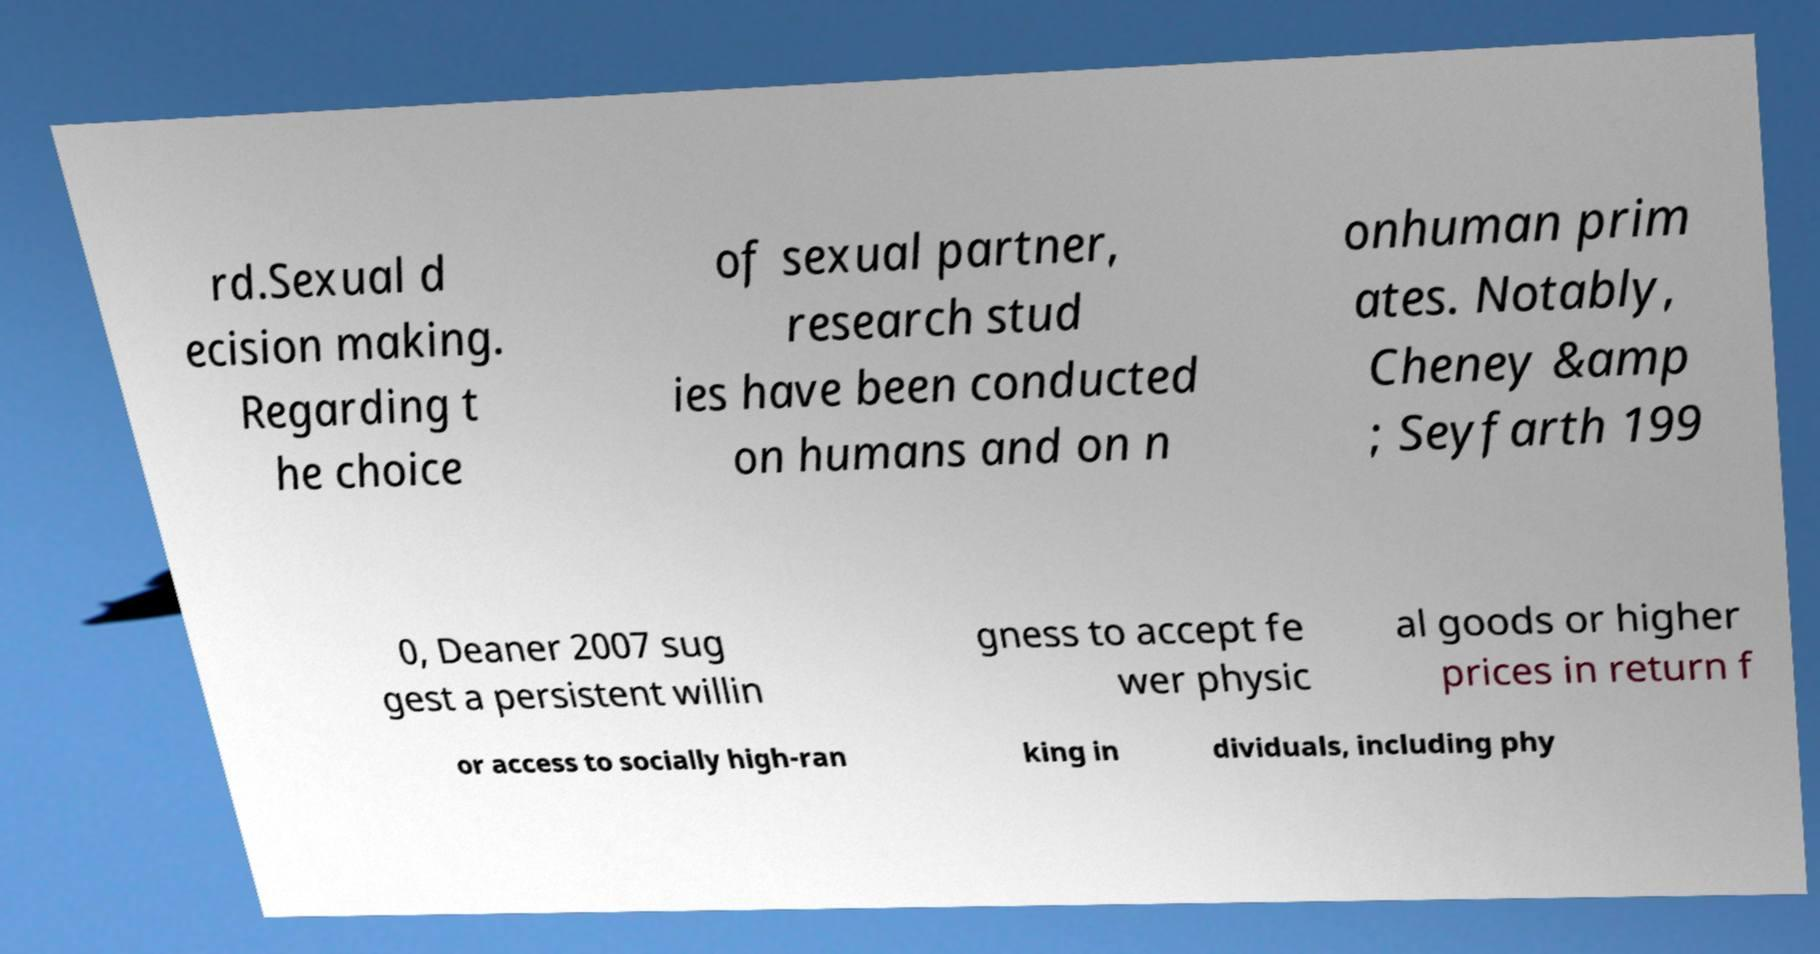Please identify and transcribe the text found in this image. rd.Sexual d ecision making. Regarding t he choice of sexual partner, research stud ies have been conducted on humans and on n onhuman prim ates. Notably, Cheney &amp ; Seyfarth 199 0, Deaner 2007 sug gest a persistent willin gness to accept fe wer physic al goods or higher prices in return f or access to socially high-ran king in dividuals, including phy 